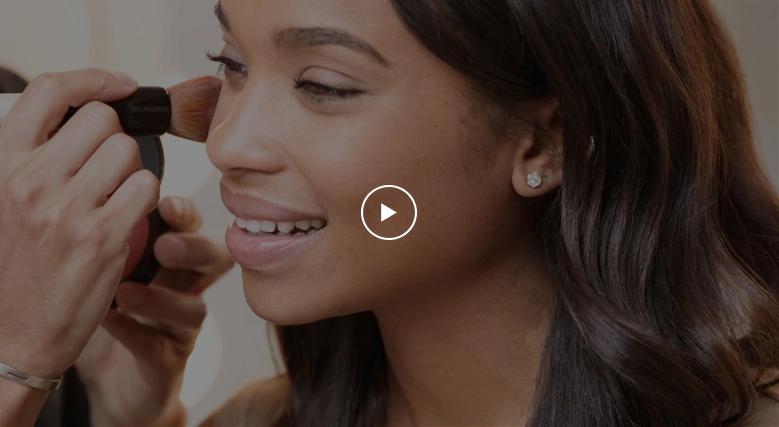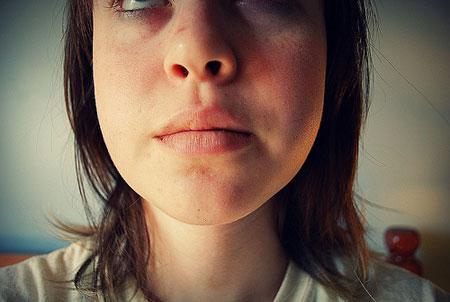The first image is the image on the left, the second image is the image on the right. Considering the images on both sides, is "There is a lady looking directly at the camera." valid? Answer yes or no. No. The first image is the image on the left, the second image is the image on the right. Assess this claim about the two images: "Three people are visible in the two images.". Correct or not? Answer yes or no. Yes. 